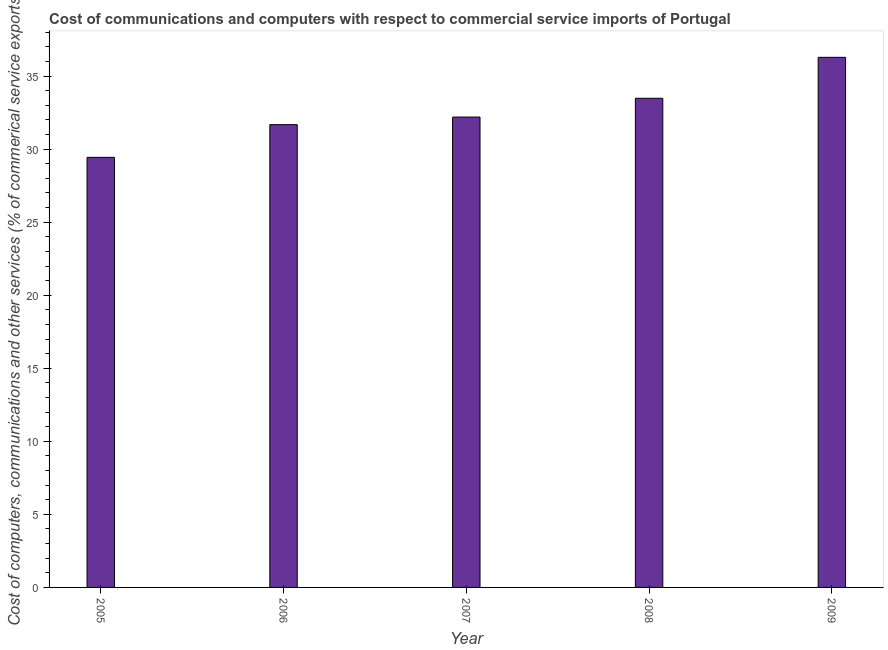What is the title of the graph?
Offer a very short reply. Cost of communications and computers with respect to commercial service imports of Portugal. What is the label or title of the X-axis?
Offer a very short reply. Year. What is the label or title of the Y-axis?
Your answer should be very brief. Cost of computers, communications and other services (% of commerical service exports). What is the  computer and other services in 2009?
Your response must be concise. 36.28. Across all years, what is the maximum cost of communications?
Provide a succinct answer. 36.28. Across all years, what is the minimum  computer and other services?
Offer a very short reply. 29.44. What is the sum of the cost of communications?
Your answer should be very brief. 163.08. What is the difference between the  computer and other services in 2006 and 2009?
Provide a succinct answer. -4.61. What is the average  computer and other services per year?
Offer a very short reply. 32.62. What is the median  computer and other services?
Give a very brief answer. 32.2. Do a majority of the years between 2006 and 2007 (inclusive) have  computer and other services greater than 7 %?
Your response must be concise. Yes. Is the difference between the  computer and other services in 2006 and 2007 greater than the difference between any two years?
Provide a short and direct response. No. What is the difference between the highest and the second highest  computer and other services?
Your answer should be compact. 2.8. What is the difference between the highest and the lowest  computer and other services?
Your answer should be compact. 6.84. In how many years, is the cost of communications greater than the average cost of communications taken over all years?
Keep it short and to the point. 2. Are all the bars in the graph horizontal?
Offer a very short reply. No. How many years are there in the graph?
Give a very brief answer. 5. Are the values on the major ticks of Y-axis written in scientific E-notation?
Give a very brief answer. No. What is the Cost of computers, communications and other services (% of commerical service exports) of 2005?
Ensure brevity in your answer.  29.44. What is the Cost of computers, communications and other services (% of commerical service exports) in 2006?
Offer a very short reply. 31.68. What is the Cost of computers, communications and other services (% of commerical service exports) of 2007?
Keep it short and to the point. 32.2. What is the Cost of computers, communications and other services (% of commerical service exports) in 2008?
Your answer should be compact. 33.48. What is the Cost of computers, communications and other services (% of commerical service exports) in 2009?
Keep it short and to the point. 36.28. What is the difference between the Cost of computers, communications and other services (% of commerical service exports) in 2005 and 2006?
Offer a very short reply. -2.24. What is the difference between the Cost of computers, communications and other services (% of commerical service exports) in 2005 and 2007?
Provide a short and direct response. -2.76. What is the difference between the Cost of computers, communications and other services (% of commerical service exports) in 2005 and 2008?
Offer a terse response. -4.04. What is the difference between the Cost of computers, communications and other services (% of commerical service exports) in 2005 and 2009?
Provide a short and direct response. -6.84. What is the difference between the Cost of computers, communications and other services (% of commerical service exports) in 2006 and 2007?
Offer a terse response. -0.52. What is the difference between the Cost of computers, communications and other services (% of commerical service exports) in 2006 and 2008?
Make the answer very short. -1.8. What is the difference between the Cost of computers, communications and other services (% of commerical service exports) in 2006 and 2009?
Keep it short and to the point. -4.61. What is the difference between the Cost of computers, communications and other services (% of commerical service exports) in 2007 and 2008?
Offer a terse response. -1.28. What is the difference between the Cost of computers, communications and other services (% of commerical service exports) in 2007 and 2009?
Give a very brief answer. -4.09. What is the difference between the Cost of computers, communications and other services (% of commerical service exports) in 2008 and 2009?
Offer a very short reply. -2.8. What is the ratio of the Cost of computers, communications and other services (% of commerical service exports) in 2005 to that in 2006?
Ensure brevity in your answer.  0.93. What is the ratio of the Cost of computers, communications and other services (% of commerical service exports) in 2005 to that in 2007?
Your answer should be compact. 0.91. What is the ratio of the Cost of computers, communications and other services (% of commerical service exports) in 2005 to that in 2008?
Give a very brief answer. 0.88. What is the ratio of the Cost of computers, communications and other services (% of commerical service exports) in 2005 to that in 2009?
Make the answer very short. 0.81. What is the ratio of the Cost of computers, communications and other services (% of commerical service exports) in 2006 to that in 2008?
Your answer should be compact. 0.95. What is the ratio of the Cost of computers, communications and other services (% of commerical service exports) in 2006 to that in 2009?
Keep it short and to the point. 0.87. What is the ratio of the Cost of computers, communications and other services (% of commerical service exports) in 2007 to that in 2008?
Make the answer very short. 0.96. What is the ratio of the Cost of computers, communications and other services (% of commerical service exports) in 2007 to that in 2009?
Make the answer very short. 0.89. What is the ratio of the Cost of computers, communications and other services (% of commerical service exports) in 2008 to that in 2009?
Your answer should be very brief. 0.92. 